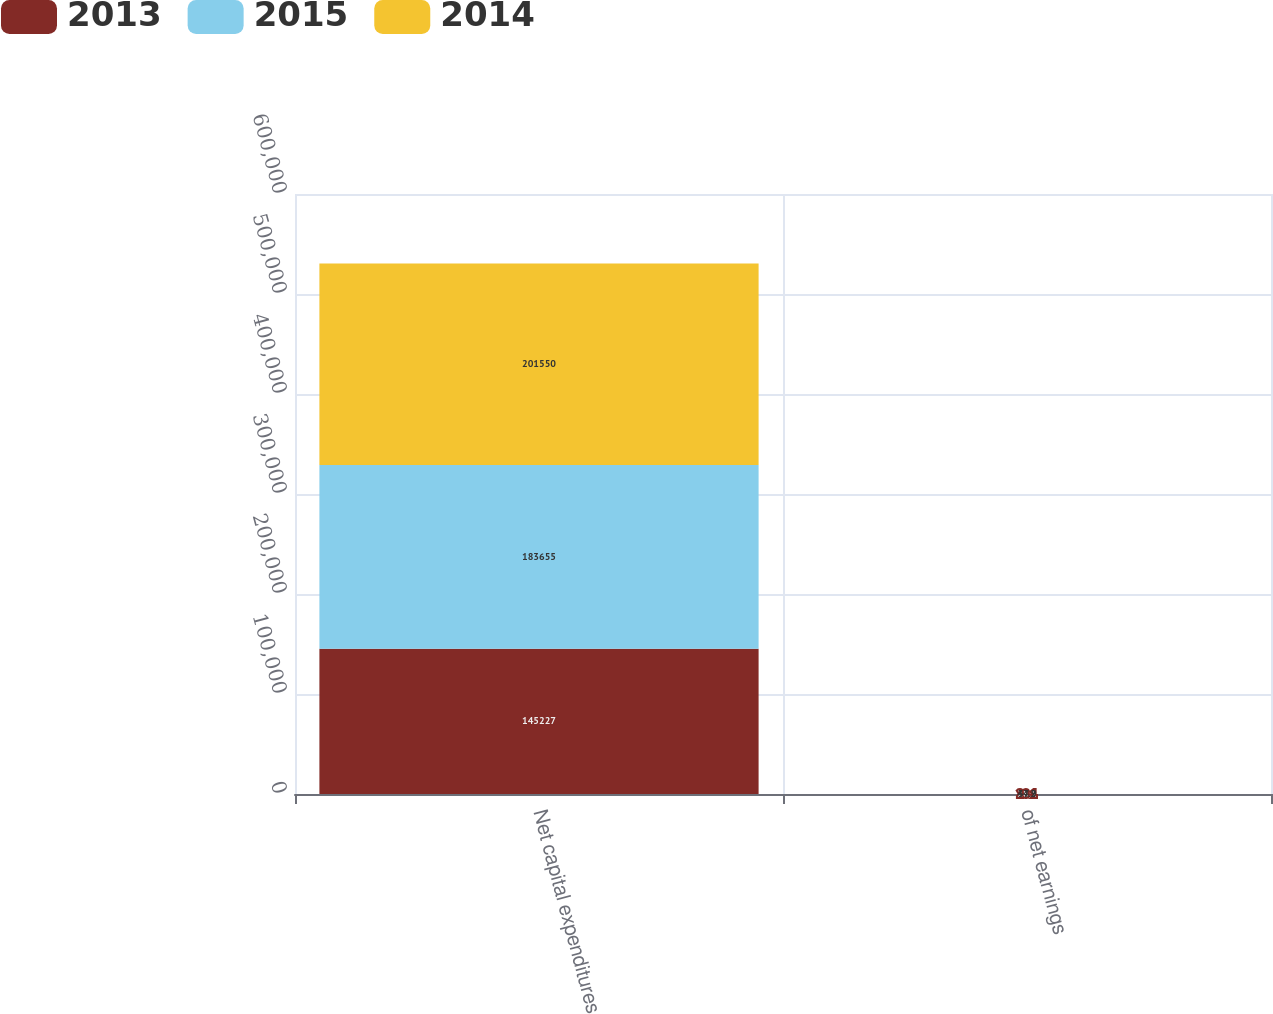Convert chart to OTSL. <chart><loc_0><loc_0><loc_500><loc_500><stacked_bar_chart><ecel><fcel>Net capital expenditures<fcel>of net earnings<nl><fcel>2013<fcel>145227<fcel>28.1<nl><fcel>2015<fcel>183655<fcel>37.2<nl><fcel>2014<fcel>201550<fcel>44.9<nl></chart> 